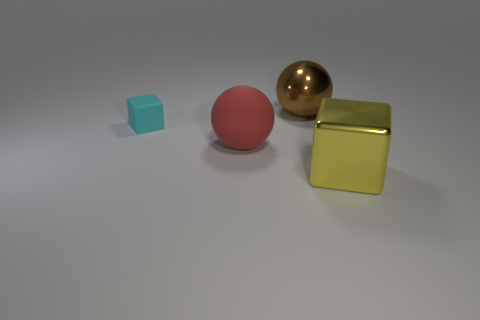Subtract all yellow blocks. Subtract all red spheres. How many blocks are left? 1 Subtract all cyan spheres. How many purple blocks are left? 0 Add 1 tiny objects. How many yellows exist? 0 Subtract all purple rubber cylinders. Subtract all red rubber balls. How many objects are left? 3 Add 2 large cubes. How many large cubes are left? 3 Add 4 large objects. How many large objects exist? 7 Add 3 shiny balls. How many objects exist? 7 Subtract all yellow blocks. How many blocks are left? 1 Subtract 0 gray spheres. How many objects are left? 4 Subtract 2 spheres. How many spheres are left? 0 